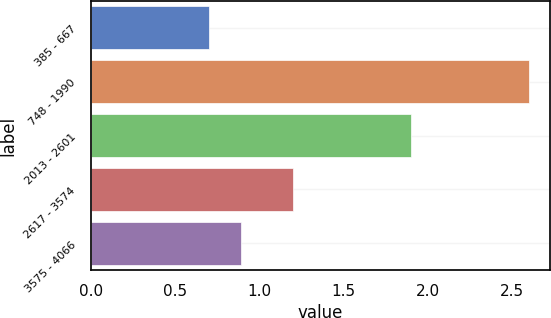Convert chart to OTSL. <chart><loc_0><loc_0><loc_500><loc_500><bar_chart><fcel>385 - 667<fcel>748 - 1990<fcel>2013 - 2601<fcel>2617 - 3574<fcel>3575 - 4066<nl><fcel>0.7<fcel>2.6<fcel>1.9<fcel>1.2<fcel>0.89<nl></chart> 